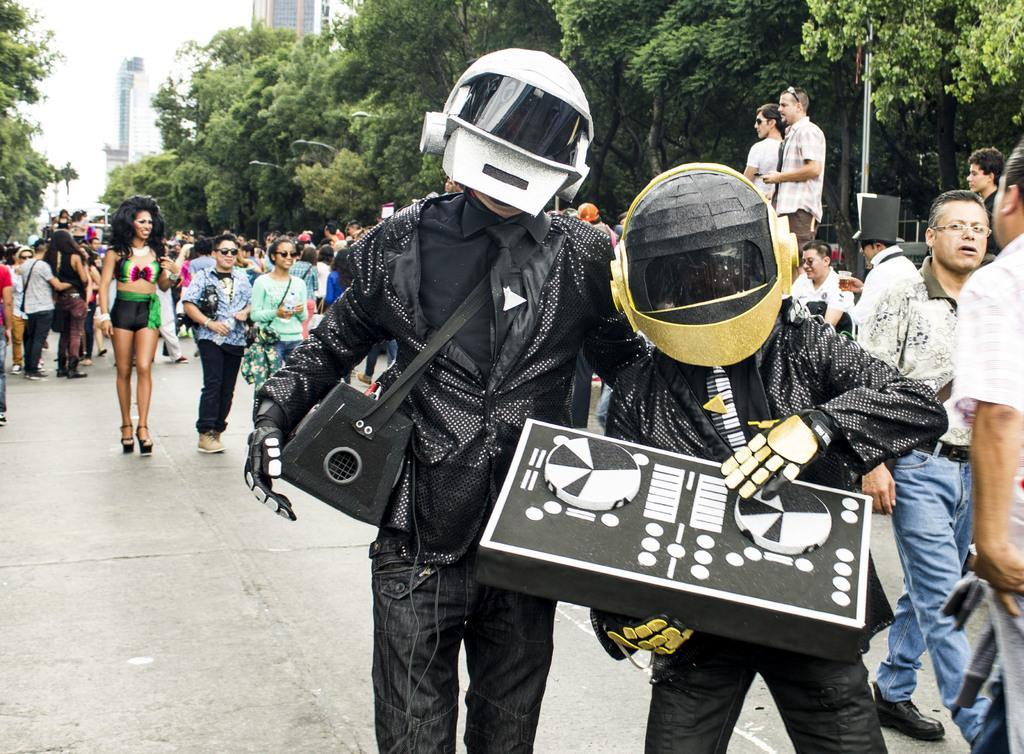Please provide a concise description of this image. In this image I can see group of people walking. They are wearing different dress. Front I can see two people wearing black dress,helmets and holding something. Back I can see buildings and trees. 